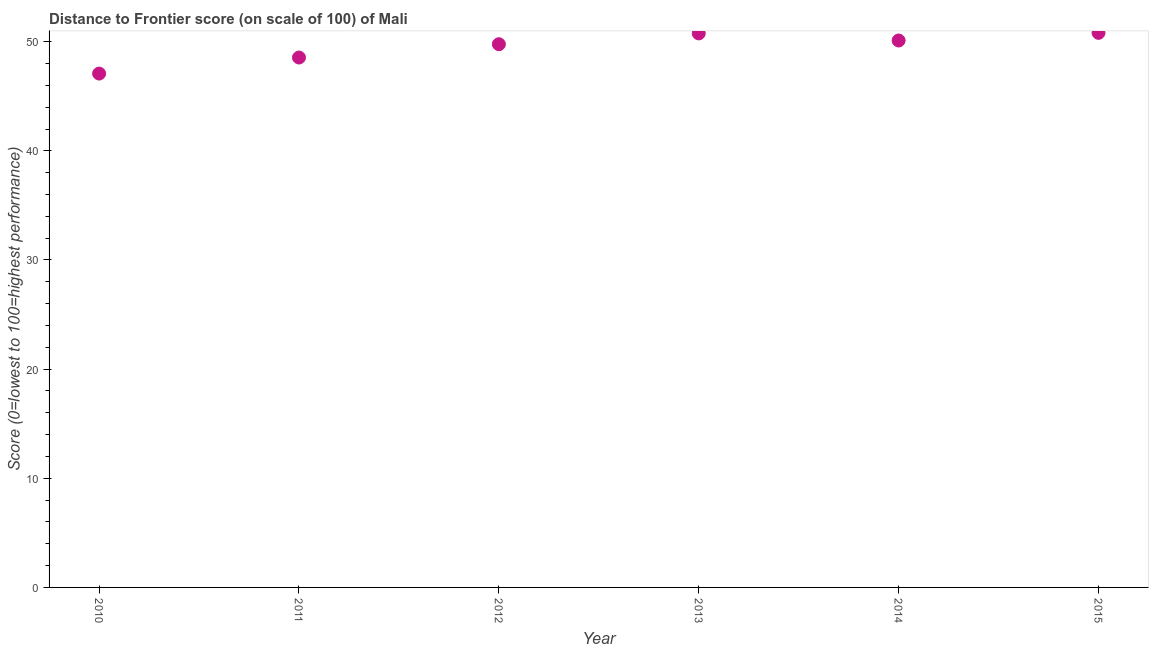What is the distance to frontier score in 2014?
Ensure brevity in your answer.  50.11. Across all years, what is the maximum distance to frontier score?
Your answer should be compact. 50.81. Across all years, what is the minimum distance to frontier score?
Ensure brevity in your answer.  47.08. In which year was the distance to frontier score maximum?
Your answer should be very brief. 2015. In which year was the distance to frontier score minimum?
Your response must be concise. 2010. What is the sum of the distance to frontier score?
Your response must be concise. 297.08. What is the difference between the distance to frontier score in 2010 and 2011?
Offer a terse response. -1.47. What is the average distance to frontier score per year?
Your answer should be compact. 49.51. What is the median distance to frontier score?
Provide a short and direct response. 49.94. In how many years, is the distance to frontier score greater than 12 ?
Your answer should be compact. 6. Do a majority of the years between 2012 and 2011 (inclusive) have distance to frontier score greater than 24 ?
Give a very brief answer. No. What is the ratio of the distance to frontier score in 2013 to that in 2014?
Provide a succinct answer. 1.01. What is the difference between the highest and the second highest distance to frontier score?
Your response must be concise. 0.05. Is the sum of the distance to frontier score in 2011 and 2015 greater than the maximum distance to frontier score across all years?
Offer a very short reply. Yes. What is the difference between the highest and the lowest distance to frontier score?
Offer a very short reply. 3.73. In how many years, is the distance to frontier score greater than the average distance to frontier score taken over all years?
Ensure brevity in your answer.  4. Does the distance to frontier score monotonically increase over the years?
Offer a very short reply. No. How many years are there in the graph?
Provide a succinct answer. 6. What is the difference between two consecutive major ticks on the Y-axis?
Provide a short and direct response. 10. Are the values on the major ticks of Y-axis written in scientific E-notation?
Provide a short and direct response. No. Does the graph contain grids?
Provide a succinct answer. No. What is the title of the graph?
Ensure brevity in your answer.  Distance to Frontier score (on scale of 100) of Mali. What is the label or title of the X-axis?
Make the answer very short. Year. What is the label or title of the Y-axis?
Provide a succinct answer. Score (0=lowest to 100=highest performance). What is the Score (0=lowest to 100=highest performance) in 2010?
Give a very brief answer. 47.08. What is the Score (0=lowest to 100=highest performance) in 2011?
Keep it short and to the point. 48.55. What is the Score (0=lowest to 100=highest performance) in 2012?
Offer a very short reply. 49.77. What is the Score (0=lowest to 100=highest performance) in 2013?
Keep it short and to the point. 50.76. What is the Score (0=lowest to 100=highest performance) in 2014?
Provide a succinct answer. 50.11. What is the Score (0=lowest to 100=highest performance) in 2015?
Provide a succinct answer. 50.81. What is the difference between the Score (0=lowest to 100=highest performance) in 2010 and 2011?
Provide a succinct answer. -1.47. What is the difference between the Score (0=lowest to 100=highest performance) in 2010 and 2012?
Ensure brevity in your answer.  -2.69. What is the difference between the Score (0=lowest to 100=highest performance) in 2010 and 2013?
Give a very brief answer. -3.68. What is the difference between the Score (0=lowest to 100=highest performance) in 2010 and 2014?
Give a very brief answer. -3.03. What is the difference between the Score (0=lowest to 100=highest performance) in 2010 and 2015?
Offer a very short reply. -3.73. What is the difference between the Score (0=lowest to 100=highest performance) in 2011 and 2012?
Offer a very short reply. -1.22. What is the difference between the Score (0=lowest to 100=highest performance) in 2011 and 2013?
Your answer should be compact. -2.21. What is the difference between the Score (0=lowest to 100=highest performance) in 2011 and 2014?
Ensure brevity in your answer.  -1.56. What is the difference between the Score (0=lowest to 100=highest performance) in 2011 and 2015?
Your response must be concise. -2.26. What is the difference between the Score (0=lowest to 100=highest performance) in 2012 and 2013?
Offer a very short reply. -0.99. What is the difference between the Score (0=lowest to 100=highest performance) in 2012 and 2014?
Ensure brevity in your answer.  -0.34. What is the difference between the Score (0=lowest to 100=highest performance) in 2012 and 2015?
Offer a terse response. -1.04. What is the difference between the Score (0=lowest to 100=highest performance) in 2013 and 2014?
Provide a succinct answer. 0.65. What is the ratio of the Score (0=lowest to 100=highest performance) in 2010 to that in 2012?
Your response must be concise. 0.95. What is the ratio of the Score (0=lowest to 100=highest performance) in 2010 to that in 2013?
Offer a terse response. 0.93. What is the ratio of the Score (0=lowest to 100=highest performance) in 2010 to that in 2014?
Make the answer very short. 0.94. What is the ratio of the Score (0=lowest to 100=highest performance) in 2010 to that in 2015?
Ensure brevity in your answer.  0.93. What is the ratio of the Score (0=lowest to 100=highest performance) in 2011 to that in 2013?
Provide a succinct answer. 0.96. What is the ratio of the Score (0=lowest to 100=highest performance) in 2011 to that in 2014?
Your answer should be very brief. 0.97. What is the ratio of the Score (0=lowest to 100=highest performance) in 2011 to that in 2015?
Offer a very short reply. 0.96. What is the ratio of the Score (0=lowest to 100=highest performance) in 2012 to that in 2014?
Your answer should be very brief. 0.99. What is the ratio of the Score (0=lowest to 100=highest performance) in 2012 to that in 2015?
Offer a terse response. 0.98. What is the ratio of the Score (0=lowest to 100=highest performance) in 2013 to that in 2014?
Make the answer very short. 1.01. What is the ratio of the Score (0=lowest to 100=highest performance) in 2013 to that in 2015?
Your response must be concise. 1. What is the ratio of the Score (0=lowest to 100=highest performance) in 2014 to that in 2015?
Provide a succinct answer. 0.99. 